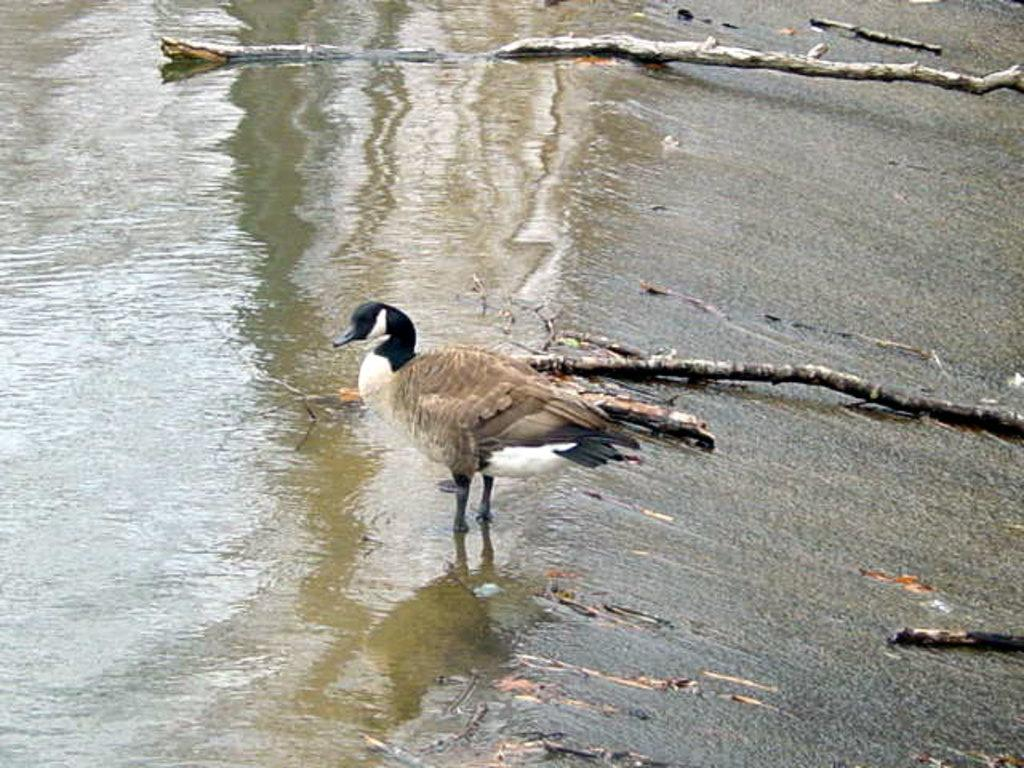What is the primary element in the image? The image consists of water. What type of animal can be seen in the water? There is a duck in the water. Are there any objects visible in the image? Yes, there are sticks in the image. What type of pet is sitting on the table in the image? There is no table or pet present in the image; it consists of water with a duck and sticks. Can you see a horse in the image? There is no horse present in the image; it consists of water with a duck and sticks. 